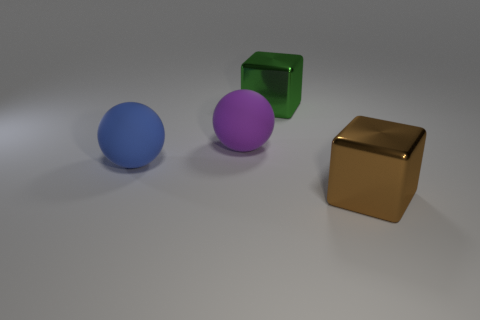What shape is the object that is left of the green metal block and to the right of the blue rubber ball?
Ensure brevity in your answer.  Sphere. There is a shiny cube that is behind the brown thing; what size is it?
Your response must be concise. Large. Does the blue rubber object have the same size as the purple matte sphere?
Make the answer very short. Yes. Is the number of rubber objects behind the green metal cube less than the number of purple matte balls on the left side of the large blue sphere?
Ensure brevity in your answer.  No. There is a object that is right of the purple sphere and on the left side of the big brown metallic thing; what is its size?
Your response must be concise. Large. There is a large cube on the right side of the big shiny object behind the brown shiny cube; is there a large metal cube that is left of it?
Provide a succinct answer. Yes. Are there any large metal blocks?
Provide a succinct answer. Yes. Are there more blue rubber balls behind the green metallic block than brown cubes in front of the brown shiny cube?
Offer a terse response. No. There is a brown block that is the same material as the large green object; what is its size?
Provide a short and direct response. Large. What is the size of the rubber ball on the left side of the big ball behind the rubber thing that is left of the large purple rubber thing?
Ensure brevity in your answer.  Large. 